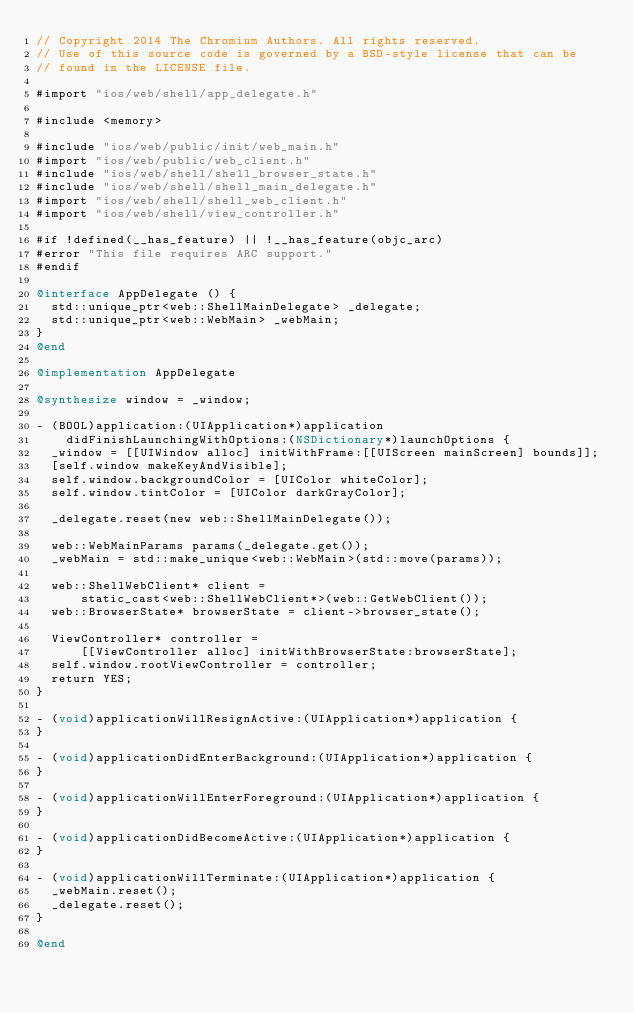Convert code to text. <code><loc_0><loc_0><loc_500><loc_500><_ObjectiveC_>// Copyright 2014 The Chromium Authors. All rights reserved.
// Use of this source code is governed by a BSD-style license that can be
// found in the LICENSE file.

#import "ios/web/shell/app_delegate.h"

#include <memory>

#include "ios/web/public/init/web_main.h"
#import "ios/web/public/web_client.h"
#include "ios/web/shell/shell_browser_state.h"
#include "ios/web/shell/shell_main_delegate.h"
#import "ios/web/shell/shell_web_client.h"
#import "ios/web/shell/view_controller.h"

#if !defined(__has_feature) || !__has_feature(objc_arc)
#error "This file requires ARC support."
#endif

@interface AppDelegate () {
  std::unique_ptr<web::ShellMainDelegate> _delegate;
  std::unique_ptr<web::WebMain> _webMain;
}
@end

@implementation AppDelegate

@synthesize window = _window;

- (BOOL)application:(UIApplication*)application
    didFinishLaunchingWithOptions:(NSDictionary*)launchOptions {
  _window = [[UIWindow alloc] initWithFrame:[[UIScreen mainScreen] bounds]];
  [self.window makeKeyAndVisible];
  self.window.backgroundColor = [UIColor whiteColor];
  self.window.tintColor = [UIColor darkGrayColor];

  _delegate.reset(new web::ShellMainDelegate());

  web::WebMainParams params(_delegate.get());
  _webMain = std::make_unique<web::WebMain>(std::move(params));

  web::ShellWebClient* client =
      static_cast<web::ShellWebClient*>(web::GetWebClient());
  web::BrowserState* browserState = client->browser_state();

  ViewController* controller =
      [[ViewController alloc] initWithBrowserState:browserState];
  self.window.rootViewController = controller;
  return YES;
}

- (void)applicationWillResignActive:(UIApplication*)application {
}

- (void)applicationDidEnterBackground:(UIApplication*)application {
}

- (void)applicationWillEnterForeground:(UIApplication*)application {
}

- (void)applicationDidBecomeActive:(UIApplication*)application {
}

- (void)applicationWillTerminate:(UIApplication*)application {
  _webMain.reset();
  _delegate.reset();
}

@end
</code> 